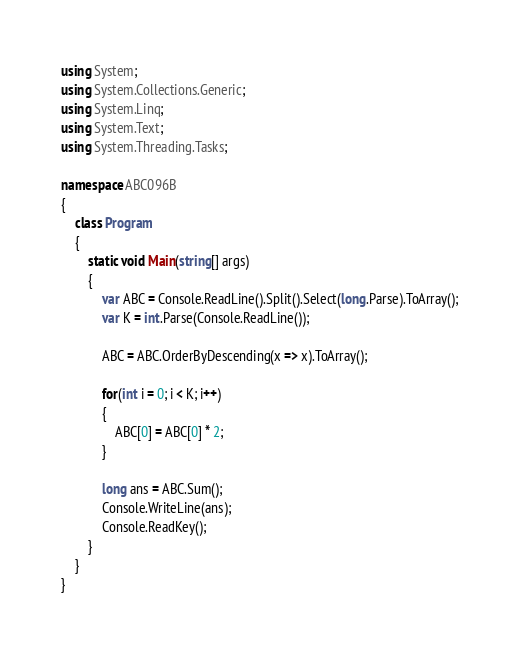<code> <loc_0><loc_0><loc_500><loc_500><_C#_>using System;
using System.Collections.Generic;
using System.Linq;
using System.Text;
using System.Threading.Tasks;

namespace ABC096B
{
    class Program
    {
        static void Main(string[] args)
        {
            var ABC = Console.ReadLine().Split().Select(long.Parse).ToArray();
            var K = int.Parse(Console.ReadLine());

            ABC = ABC.OrderByDescending(x => x).ToArray();

            for(int i = 0; i < K; i++)
            {
                ABC[0] = ABC[0] * 2;
            }

            long ans = ABC.Sum();
            Console.WriteLine(ans);
            Console.ReadKey();
        }
    }
}
</code> 